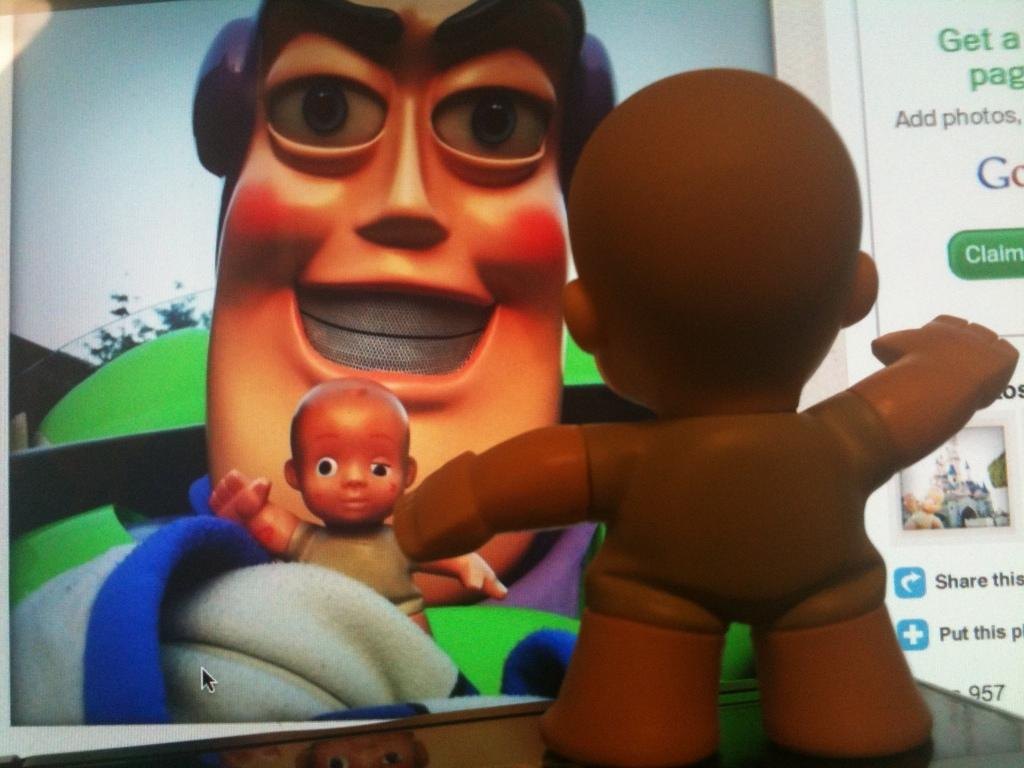What object can be seen in the image that is meant for play or amusement? There is a toy in the image. What is hanging on the wall in the image? There is a poster in the image. What is depicted on the poster? The poster contains two toys, a tree, and a sky. How many fingers can be seen pointing at the toys on the poster? There are no fingers visible in the image, as it only features a toy, a poster, and the elements depicted on the poster. 